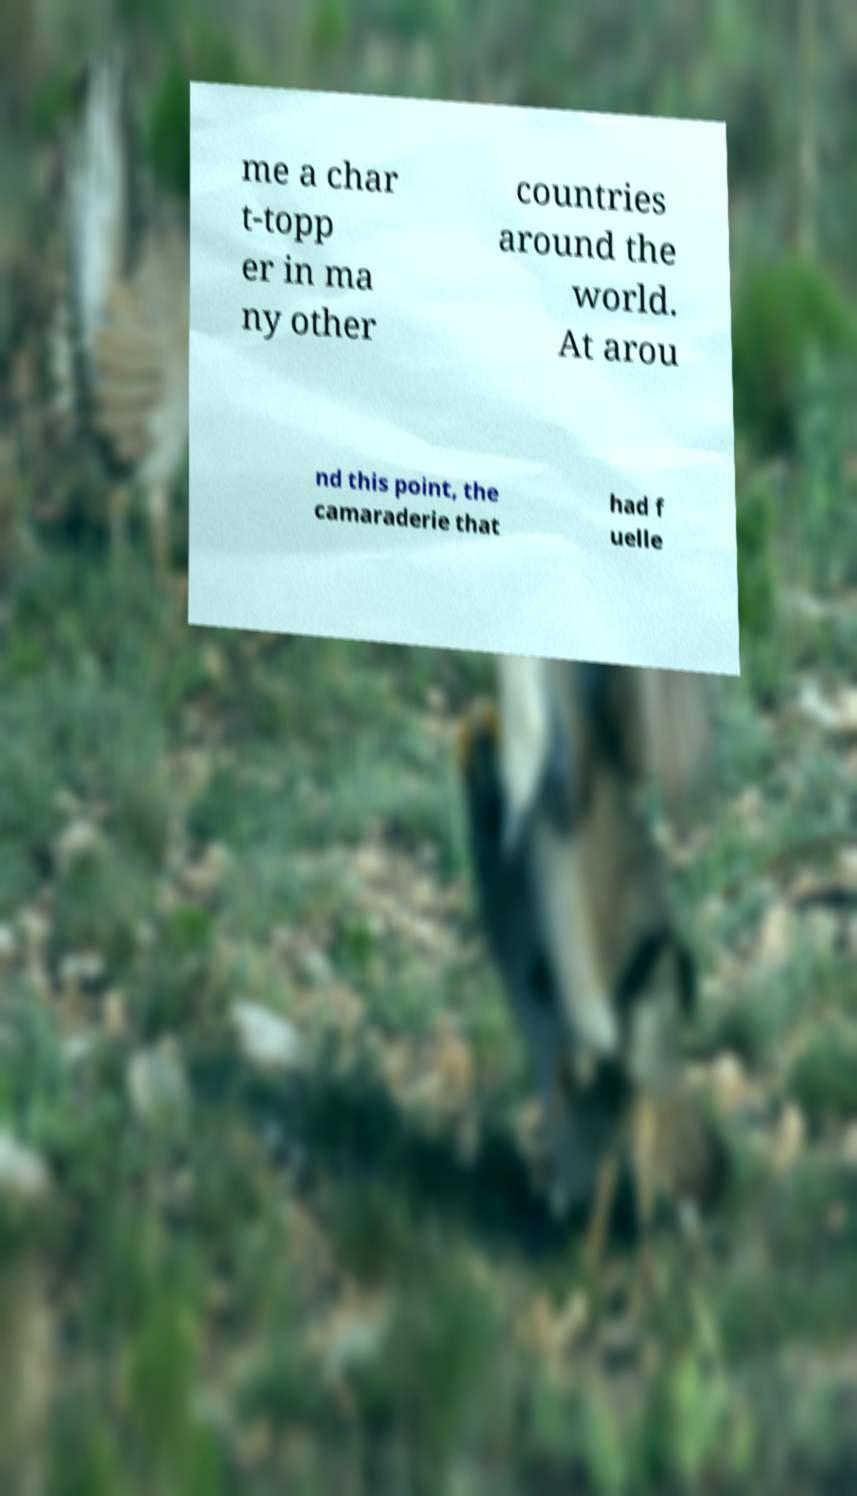Could you extract and type out the text from this image? me a char t-topp er in ma ny other countries around the world. At arou nd this point, the camaraderie that had f uelle 